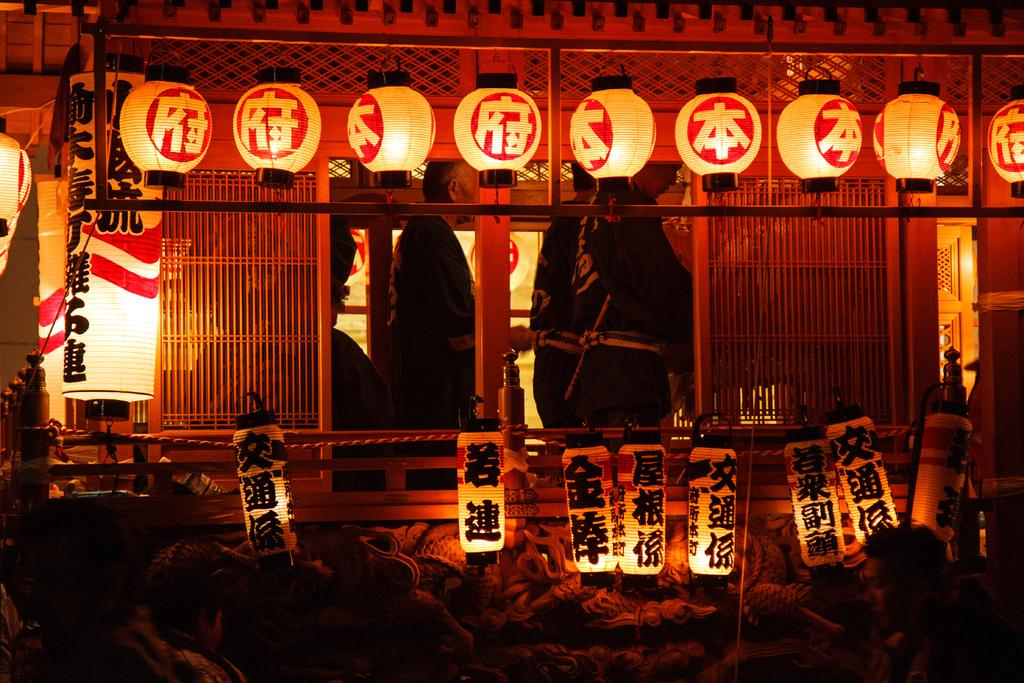How many people are in the group visible in the image? There is a group of persons standing in the image, but the exact number cannot be determined from the provided facts. What is located above the group of persons? There are lights visible above the group of persons. What else can be seen in the image besides the group of persons and the lights? There are objects present in the image, but their specific nature cannot be determined from the provided facts. How would you describe the lighting conditions in the image? The environment in the image appears to be dark, with lights visible above the group of persons. What type of plough is being used by the person in the image? There is no plough present in the image; it features a group of persons standing with lights visible above them. How much debt is being discussed by the group in the image? There is no indication of any financial discussions or debt in the image; it simply shows a group of persons standing with lights visible above them. 